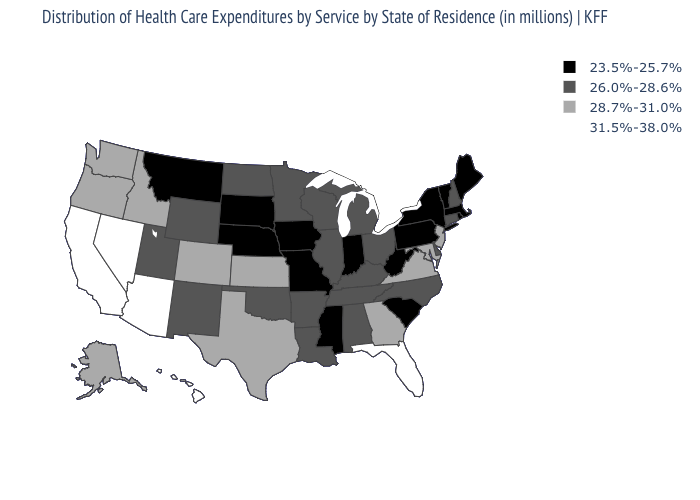Name the states that have a value in the range 31.5%-38.0%?
Quick response, please. Arizona, California, Florida, Hawaii, Nevada. How many symbols are there in the legend?
Be succinct. 4. What is the value of Florida?
Write a very short answer. 31.5%-38.0%. What is the value of Nebraska?
Quick response, please. 23.5%-25.7%. What is the value of Iowa?
Keep it brief. 23.5%-25.7%. Name the states that have a value in the range 28.7%-31.0%?
Concise answer only. Alaska, Colorado, Georgia, Idaho, Kansas, Maryland, New Jersey, Oregon, Texas, Virginia, Washington. Does North Dakota have the highest value in the USA?
Keep it brief. No. What is the value of Georgia?
Give a very brief answer. 28.7%-31.0%. What is the value of Hawaii?
Write a very short answer. 31.5%-38.0%. What is the highest value in the South ?
Concise answer only. 31.5%-38.0%. What is the value of Oregon?
Be succinct. 28.7%-31.0%. Is the legend a continuous bar?
Quick response, please. No. Name the states that have a value in the range 31.5%-38.0%?
Be succinct. Arizona, California, Florida, Hawaii, Nevada. Name the states that have a value in the range 23.5%-25.7%?
Concise answer only. Indiana, Iowa, Maine, Massachusetts, Mississippi, Missouri, Montana, Nebraska, New York, Pennsylvania, Rhode Island, South Carolina, South Dakota, Vermont, West Virginia. Among the states that border Washington , which have the lowest value?
Keep it brief. Idaho, Oregon. 